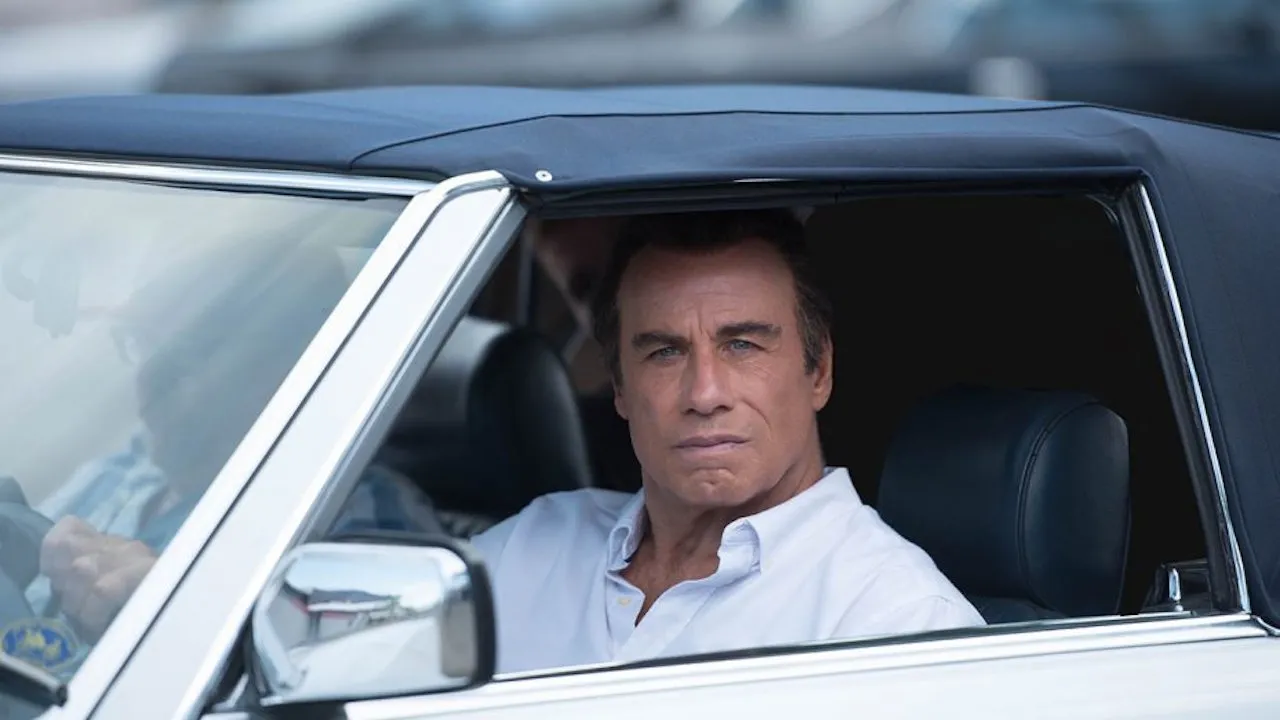Can you describe the setting of the scene shown in the image? The setting is a parking lot bustling with activity. Several other cars are parked nearby, and there appears to be moderate foot traffic in the background, indicating that the area is public and possibly near a busy venue or event. 